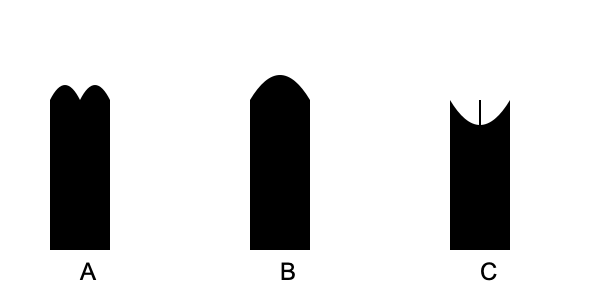Which silhouette demonstrates the correct form for a safe and effective deadlift? To identify the correct form for a safe and effective deadlift, let's analyze each silhouette:

1. Silhouette A:
   - The back is rounded, which can lead to spinal injuries.
   - The bar appears to be away from the body, increasing stress on the lower back.

2. Silhouette B:
   - The back is excessively arched, which can cause hyperextension and lower back strain.
   - The bar seems to be in contact with the legs, which is good, but the overall posture is not ideal.

3. Silhouette C:
   - The back is in a neutral position, maintaining its natural curve.
   - The bar is close to the body, reducing stress on the lower back.
   - The hips are slightly higher than the knees, indicating proper hip hinge.

The correct form for a deadlift involves:
- Maintaining a neutral spine throughout the movement.
- Keeping the bar close to the body.
- Hinging at the hips while keeping the chest up.
- Engaging the core and leg muscles to lift the weight.

Silhouette C demonstrates all these aspects, making it the safest and most effective form for a deadlift.
Answer: C 